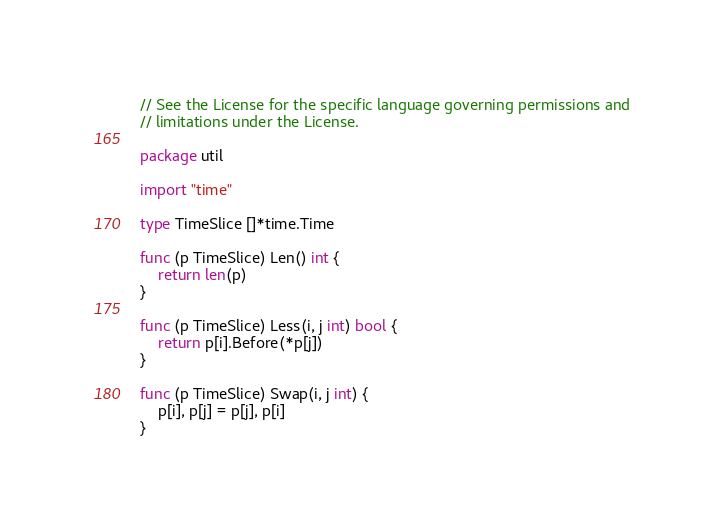Convert code to text. <code><loc_0><loc_0><loc_500><loc_500><_Go_>// See the License for the specific language governing permissions and
// limitations under the License.

package util

import "time"

type TimeSlice []*time.Time

func (p TimeSlice) Len() int {
	return len(p)
}

func (p TimeSlice) Less(i, j int) bool {
	return p[i].Before(*p[j])
}

func (p TimeSlice) Swap(i, j int) {
	p[i], p[j] = p[j], p[i]
}
</code> 